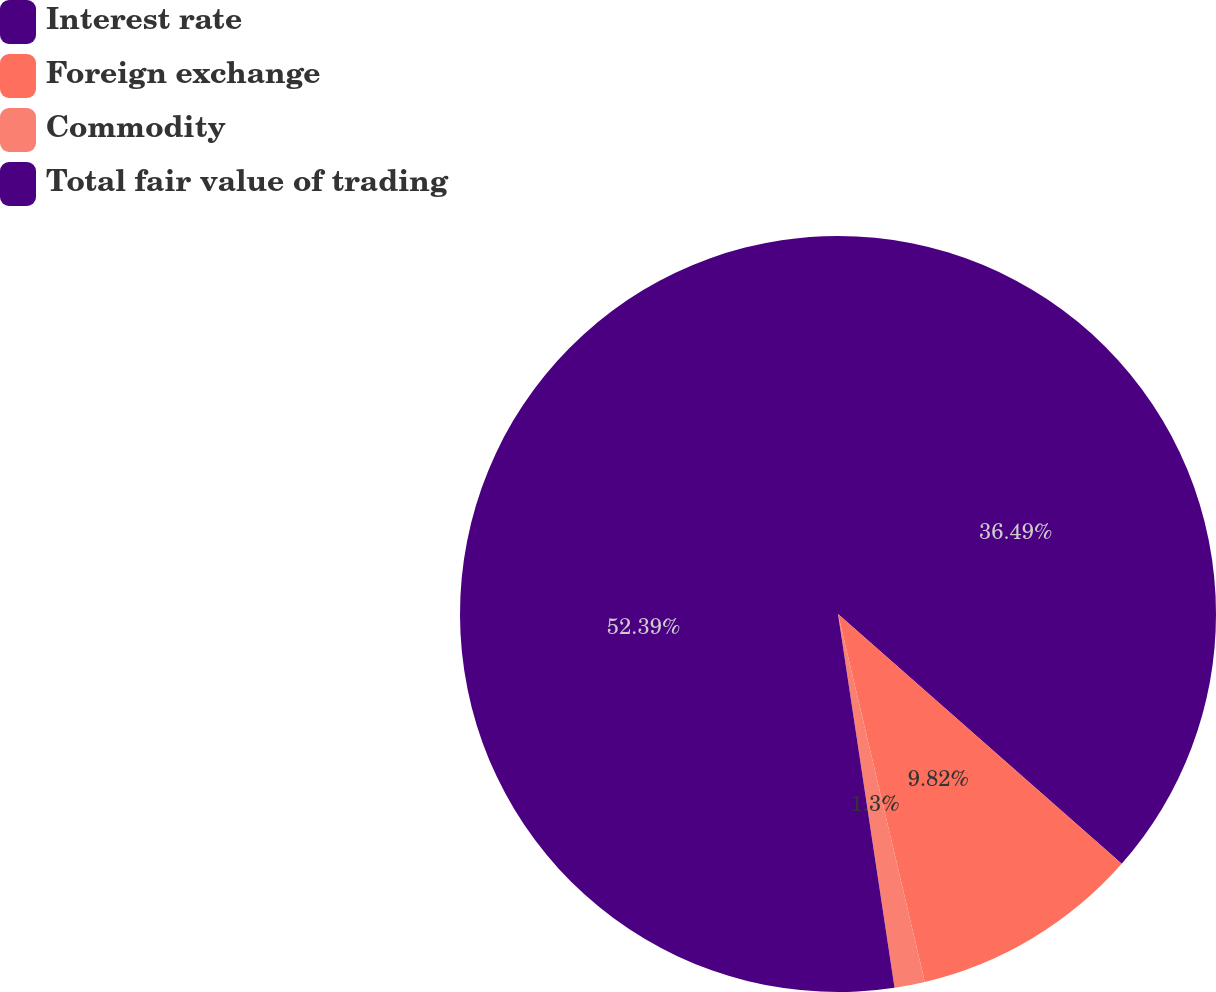<chart> <loc_0><loc_0><loc_500><loc_500><pie_chart><fcel>Interest rate<fcel>Foreign exchange<fcel>Commodity<fcel>Total fair value of trading<nl><fcel>36.49%<fcel>9.82%<fcel>1.3%<fcel>52.39%<nl></chart> 